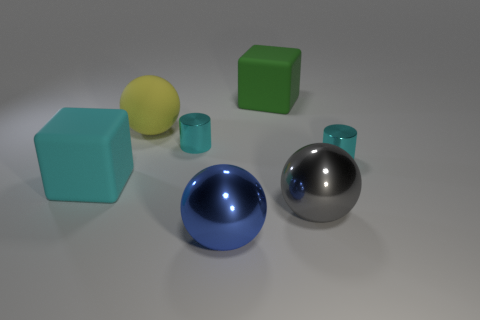Add 3 big blue metal objects. How many objects exist? 10 Subtract all cylinders. How many objects are left? 5 Subtract all cyan rubber cubes. Subtract all rubber spheres. How many objects are left? 5 Add 4 small metal objects. How many small metal objects are left? 6 Add 2 small red blocks. How many small red blocks exist? 2 Subtract 0 gray cubes. How many objects are left? 7 